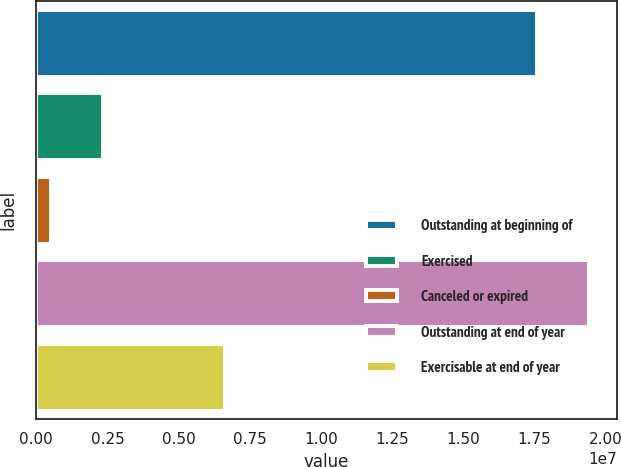Convert chart. <chart><loc_0><loc_0><loc_500><loc_500><bar_chart><fcel>Outstanding at beginning of<fcel>Exercised<fcel>Canceled or expired<fcel>Outstanding at end of year<fcel>Exercisable at end of year<nl><fcel>1.758e+07<fcel>2.35353e+06<fcel>508083<fcel>1.94255e+07<fcel>6.62634e+06<nl></chart> 